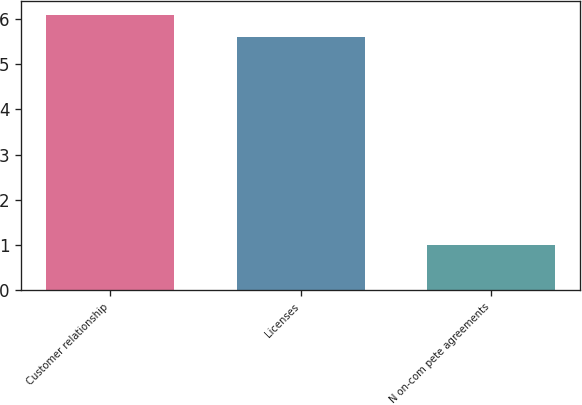<chart> <loc_0><loc_0><loc_500><loc_500><bar_chart><fcel>Customer relationship<fcel>Licenses<fcel>N on-com pete agreements<nl><fcel>6.1<fcel>5.6<fcel>1<nl></chart> 